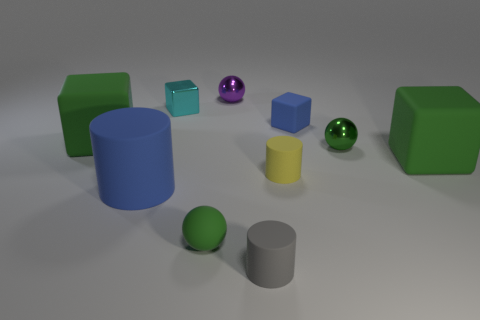How many small blue matte things are behind the tiny metal sphere left of the yellow cylinder?
Your answer should be compact. 0. Does the yellow rubber cylinder have the same size as the purple ball on the right side of the green rubber sphere?
Your response must be concise. Yes. Does the blue cube have the same size as the purple sphere?
Keep it short and to the point. Yes. Are there any gray objects of the same size as the purple metallic thing?
Provide a short and direct response. Yes. What material is the blue thing on the left side of the blue block?
Offer a terse response. Rubber. What is the color of the sphere that is the same material as the blue cylinder?
Your response must be concise. Green. How many matte objects are either cyan objects or brown things?
Offer a terse response. 0. There is a green metallic thing that is the same size as the cyan metallic block; what shape is it?
Provide a short and direct response. Sphere. What number of things are either small green matte spheres on the left side of the purple sphere or blue objects on the right side of the purple sphere?
Offer a very short reply. 2. What material is the other block that is the same size as the blue cube?
Provide a succinct answer. Metal. 